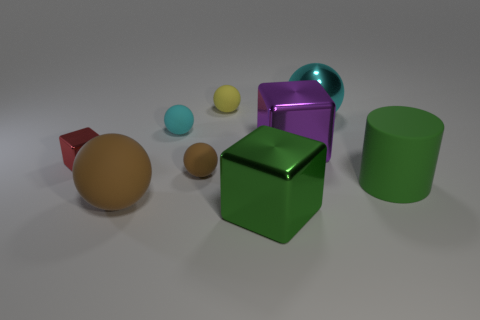How many things are tiny rubber balls that are behind the large purple thing or tiny cyan rubber cylinders? Looking at the image, we can see two tiny rubber balls behind the large purple object and no tiny cyan rubber cylinders. So the total count is 2. 